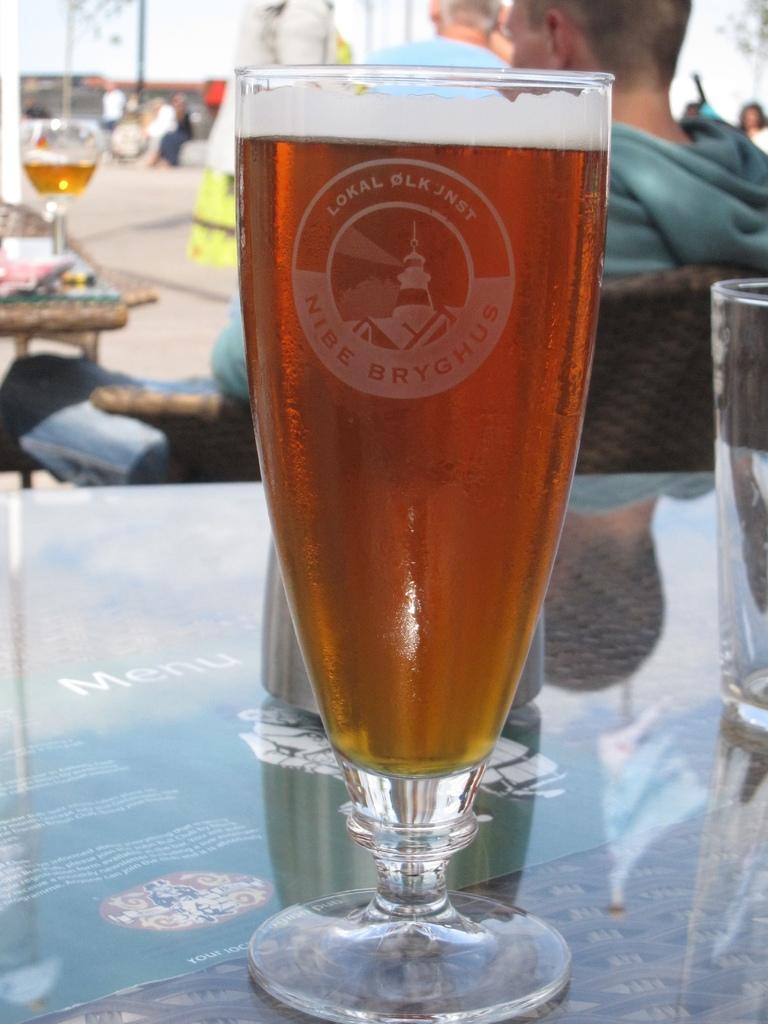What is sitting inside the glass of the table?
Give a very brief answer. Answering does not require reading text in the image. 